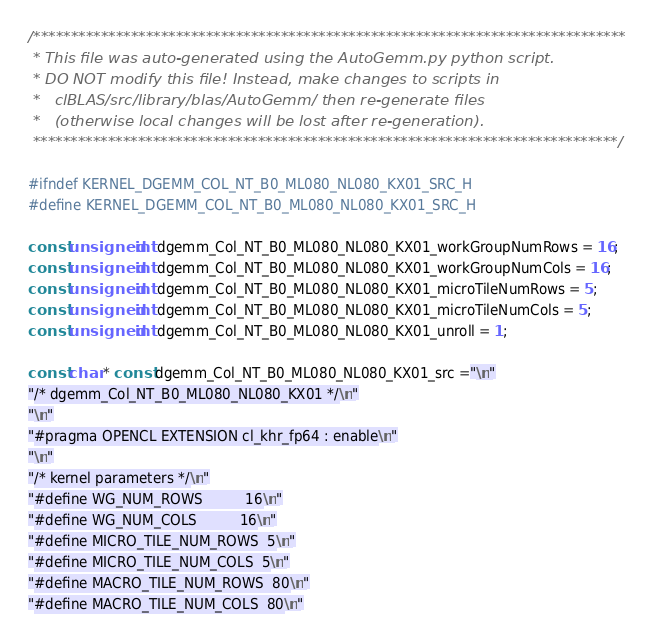Convert code to text. <code><loc_0><loc_0><loc_500><loc_500><_C++_>/*******************************************************************************
 * This file was auto-generated using the AutoGemm.py python script.
 * DO NOT modify this file! Instead, make changes to scripts in
 *   clBLAS/src/library/blas/AutoGemm/ then re-generate files
 *   (otherwise local changes will be lost after re-generation).
 ******************************************************************************/

#ifndef KERNEL_DGEMM_COL_NT_B0_ML080_NL080_KX01_SRC_H
#define KERNEL_DGEMM_COL_NT_B0_ML080_NL080_KX01_SRC_H

const unsigned int dgemm_Col_NT_B0_ML080_NL080_KX01_workGroupNumRows = 16;
const unsigned int dgemm_Col_NT_B0_ML080_NL080_KX01_workGroupNumCols = 16;
const unsigned int dgemm_Col_NT_B0_ML080_NL080_KX01_microTileNumRows = 5;
const unsigned int dgemm_Col_NT_B0_ML080_NL080_KX01_microTileNumCols = 5;
const unsigned int dgemm_Col_NT_B0_ML080_NL080_KX01_unroll = 1;

const char * const dgemm_Col_NT_B0_ML080_NL080_KX01_src ="\n"
"/* dgemm_Col_NT_B0_ML080_NL080_KX01 */\n"
"\n"
"#pragma OPENCL EXTENSION cl_khr_fp64 : enable\n"
"\n"
"/* kernel parameters */\n"
"#define WG_NUM_ROWS          16\n"
"#define WG_NUM_COLS          16\n"
"#define MICRO_TILE_NUM_ROWS  5\n"
"#define MICRO_TILE_NUM_COLS  5\n"
"#define MACRO_TILE_NUM_ROWS  80\n"
"#define MACRO_TILE_NUM_COLS  80\n"</code> 